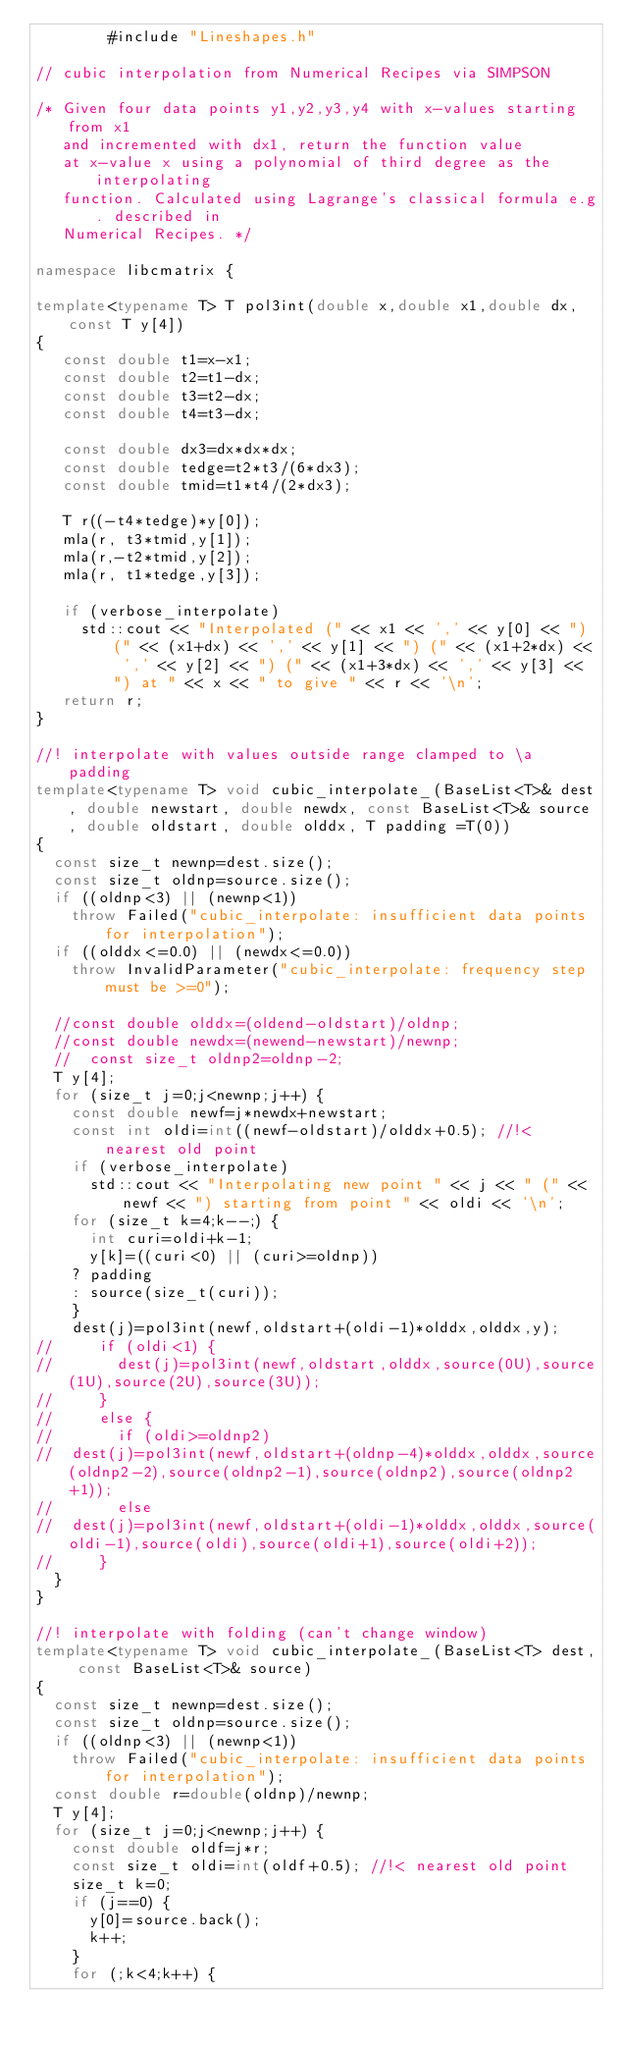<code> <loc_0><loc_0><loc_500><loc_500><_C++_>		#include "Lineshapes.h"

// cubic interpolation from Numerical Recipes via SIMPSON 

/* Given four data points y1,y2,y3,y4 with x-values starting from x1
   and incremented with dx1, return the function value
   at x-value x using a polynomial of third degree as the interpolating
   function. Calculated using Lagrange's classical formula e.g. described in
   Numerical Recipes. */

namespace libcmatrix {

template<typename T> T pol3int(double x,double x1,double dx,const T y[4])
{   
   const double t1=x-x1;
   const double t2=t1-dx;
   const double t3=t2-dx;
   const double t4=t3-dx;

   const double dx3=dx*dx*dx;
   const double tedge=t2*t3/(6*dx3);
   const double tmid=t1*t4/(2*dx3);

   T r((-t4*tedge)*y[0]);
   mla(r, t3*tmid,y[1]);
   mla(r,-t2*tmid,y[2]);
   mla(r, t1*tedge,y[3]);
  
   if (verbose_interpolate)
     std::cout << "Interpolated (" << x1 << ',' << y[0] << ") (" << (x1+dx) << ',' << y[1] << ") (" << (x1+2*dx) << ',' << y[2] << ") (" << (x1+3*dx) << ',' << y[3] << ") at " << x << " to give " << r << '\n'; 
   return r;   
}

//! interpolate with values outside range clamped to \a padding
template<typename T> void cubic_interpolate_(BaseList<T>& dest, double newstart, double newdx, const BaseList<T>& source, double oldstart, double olddx, T padding =T(0))
{
  const size_t newnp=dest.size();
  const size_t oldnp=source.size();
  if ((oldnp<3) || (newnp<1))
    throw Failed("cubic_interpolate: insufficient data points for interpolation");
  if ((olddx<=0.0) || (newdx<=0.0))
    throw InvalidParameter("cubic_interpolate: frequency step must be >=0");

  //const double olddx=(oldend-oldstart)/oldnp;
  //const double newdx=(newend-newstart)/newnp;
  //  const size_t oldnp2=oldnp-2;
  T y[4];
  for (size_t j=0;j<newnp;j++) {
    const double newf=j*newdx+newstart;
    const int oldi=int((newf-oldstart)/olddx+0.5); //!< nearest old point
    if (verbose_interpolate)
      std::cout << "Interpolating new point " << j << " (" << newf << ") starting from point " << oldi << '\n';
    for (size_t k=4;k--;) {
      int curi=oldi+k-1;
      y[k]=((curi<0) || (curi>=oldnp))
	? padding
	: source(size_t(curi));
    }
    dest(j)=pol3int(newf,oldstart+(oldi-1)*olddx,olddx,y);
//     if (oldi<1) {
//       dest(j)=pol3int(newf,oldstart,olddx,source(0U),source(1U),source(2U),source(3U));
//     }
//     else {
//       if (oldi>=oldnp2)
// 	dest(j)=pol3int(newf,oldstart+(oldnp-4)*olddx,olddx,source(oldnp2-2),source(oldnp2-1),source(oldnp2),source(oldnp2+1));
//       else
// 	dest(j)=pol3int(newf,oldstart+(oldi-1)*olddx,olddx,source(oldi-1),source(oldi),source(oldi+1),source(oldi+2));
//     }   
  }
}

//! interpolate with folding (can't change window)
template<typename T> void cubic_interpolate_(BaseList<T> dest, const BaseList<T>& source)
{
  const size_t newnp=dest.size();
  const size_t oldnp=source.size();
  if ((oldnp<3) || (newnp<1))
    throw Failed("cubic_interpolate: insufficient data points for interpolation");
  const double r=double(oldnp)/newnp;
  T y[4];
  for (size_t j=0;j<newnp;j++) {
    const double oldf=j*r;
    const size_t oldi=int(oldf+0.5); //!< nearest old point
    size_t k=0;
    if (j==0) {
      y[0]=source.back();
      k++;
    }    
    for (;k<4;k++) {</code> 